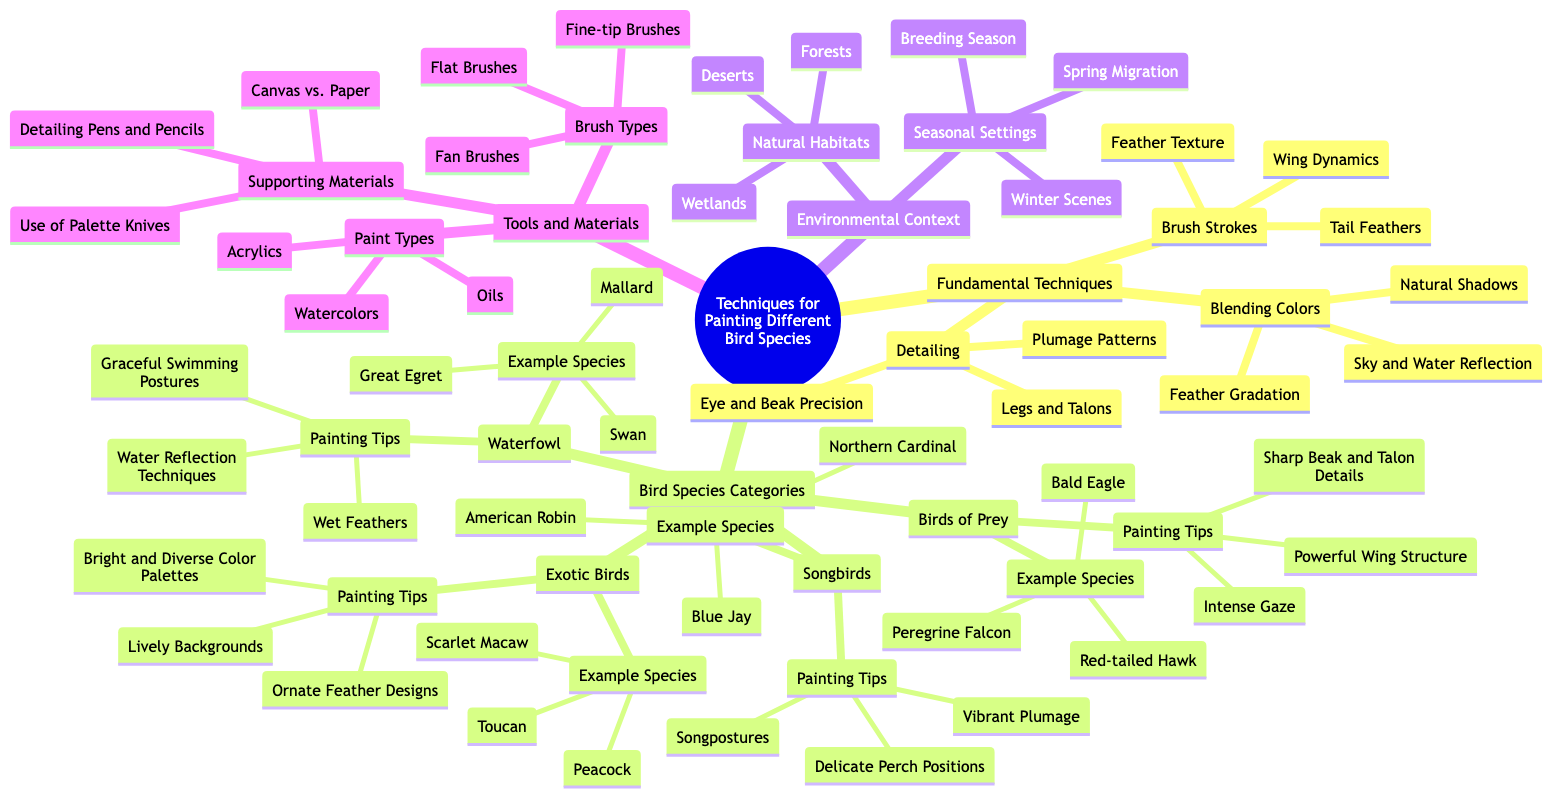What are the three main categories of techniques in the diagram? The diagram lists three main categories under "Techniques for Painting Different Bird Species": "Fundamental Techniques", "Bird Species Categories", and "Environmental Context".
Answer: Fundamental Techniques, Bird Species Categories, Environmental Context Which bird species is listed under "Songbirds"? The diagram explicitly includes "American Robin", "Northern Cardinal", and "Blue Jay" as examples under the "Songbirds" category.
Answer: American Robin, Northern Cardinal, Blue Jay How many painting tips are provided for "Waterfowl"? Under the "Waterfowl" category, there are three painting tips: "Water Reflection Techniques", "Wet Feathers", and "Graceful Swimming Postures", totaling three tips.
Answer: 3 What is one type of brush mentioned in "Brush Types"? The diagram lists "Fine-tip Brushes", "Fan Brushes", and "Flat Brushes" under "Brush Types", so any of these would answer the question.
Answer: Fine-tip Brushes Name a natural habitat mentioned in the "Environmental Context". The diagram includes "Forests", "Wetlands", and "Deserts" as natural habitats, and any of these can be an answer.
Answer: Forests What is a detailing technique related to birds? The diagram shows "Eye and Beak Precision" under "Detailing" within "Fundamental Techniques", which is one of the detailing techniques mentioned.
Answer: Eye and Beak Precision What painting tip is specific to "Exotic Birds"? The painting tips listed under "Exotic Birds" include "Bright and Diverse Color Palettes", "Ornate Feather Designs", and "Lively Backgrounds", and any of these could be a valid response.
Answer: Bright and Diverse Color Palettes How many example species are listed under "Birds of Prey"? The "Birds of Prey" category includes "Bald Eagle", "Peregrine Falcon", and "Red-tailed Hawk", which adds up to three species.
Answer: 3 What types of paint are mentioned? The diagram mentions "Watercolors", "Acrylics", and "Oils" as types of paint under "Paint Types".
Answer: Watercolors, Acrylics, Oils 